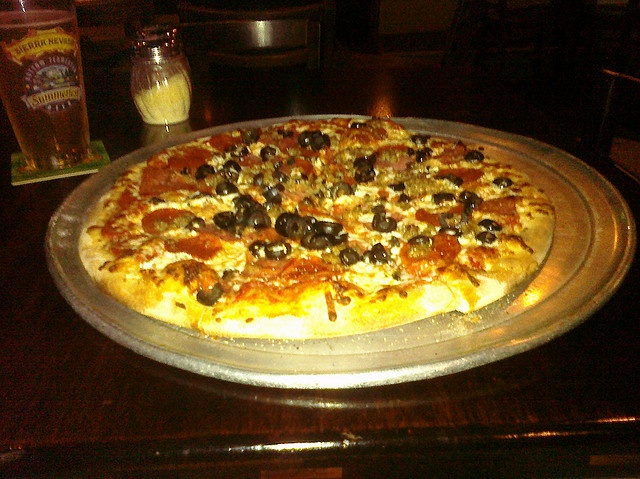Describe the objects in this image and their specific colors. I can see pizza in black, olive, orange, maroon, and khaki tones, cup in black, maroon, and olive tones, bottle in black, maroon, and olive tones, bottle in black, maroon, and khaki tones, and chair in black, maroon, gray, and tan tones in this image. 